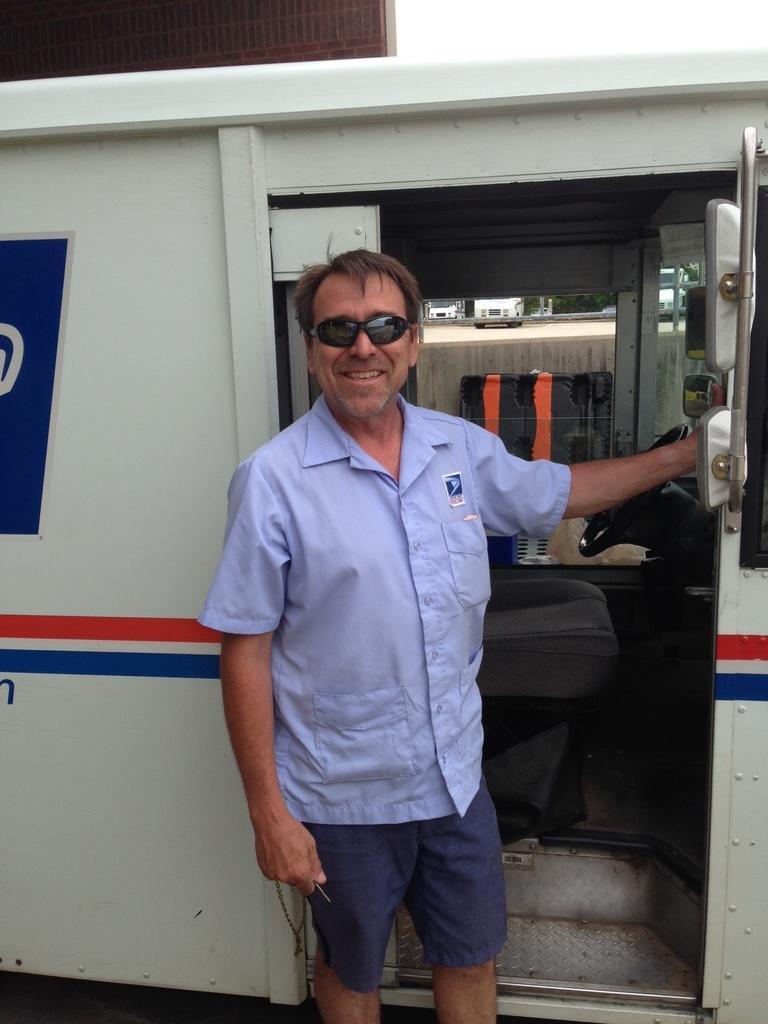Can you describe this image briefly? In the middle of this image, we can see there is a person in a blue color shirt, smiling and holding a door of a vehicle. In the background, there are vehicles and other objects. 